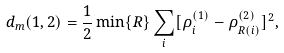<formula> <loc_0><loc_0><loc_500><loc_500>d _ { m } ( 1 , 2 ) = \frac { 1 } { 2 } \min \{ { R } \} \sum _ { i } [ \rho _ { i } ^ { ( 1 ) } - \rho _ { { R } ( i ) } ^ { ( 2 ) } ] ^ { 2 } ,</formula> 